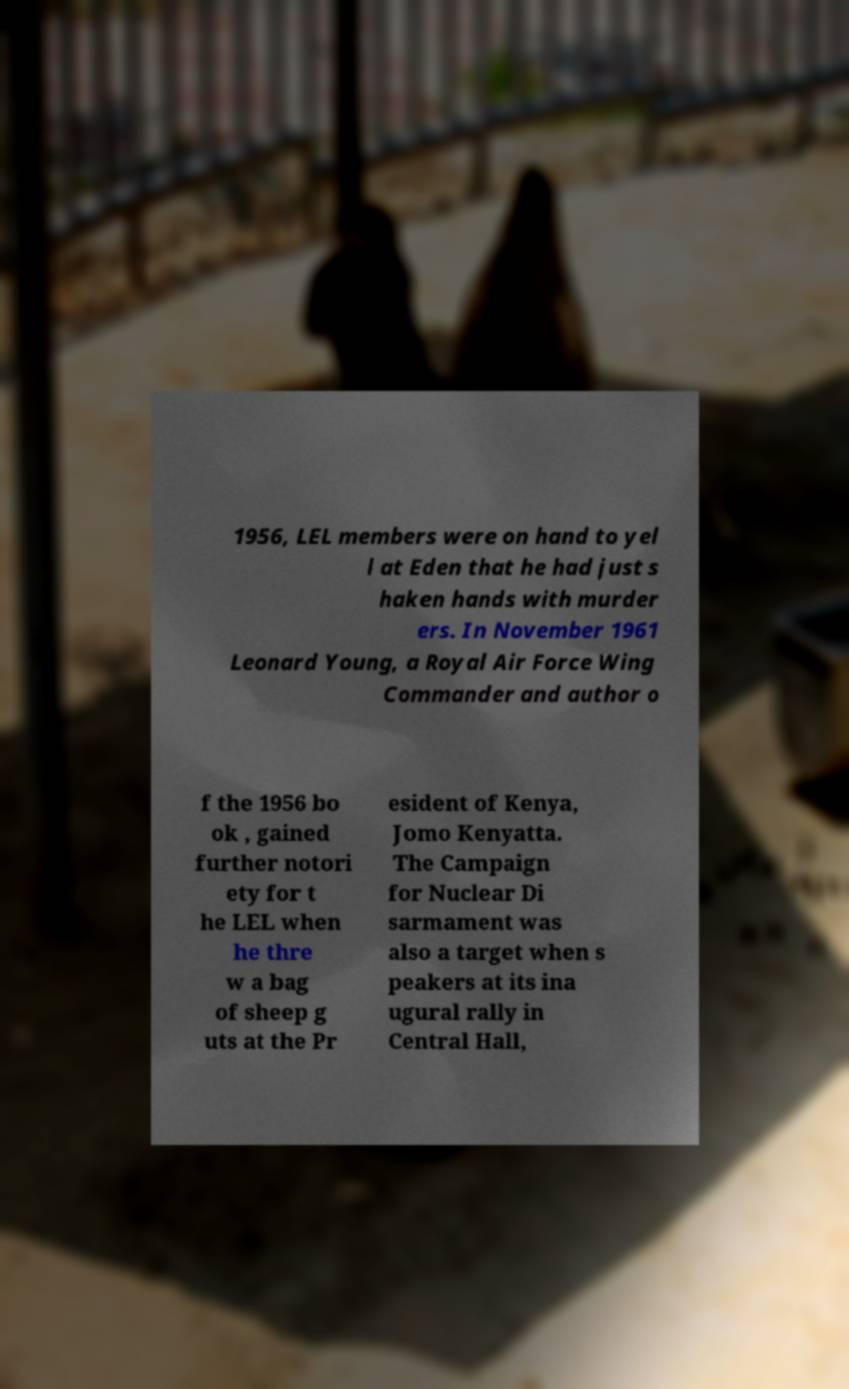Could you assist in decoding the text presented in this image and type it out clearly? 1956, LEL members were on hand to yel l at Eden that he had just s haken hands with murder ers. In November 1961 Leonard Young, a Royal Air Force Wing Commander and author o f the 1956 bo ok , gained further notori ety for t he LEL when he thre w a bag of sheep g uts at the Pr esident of Kenya, Jomo Kenyatta. The Campaign for Nuclear Di sarmament was also a target when s peakers at its ina ugural rally in Central Hall, 